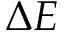Convert formula to latex. <formula><loc_0><loc_0><loc_500><loc_500>\Delta E</formula> 